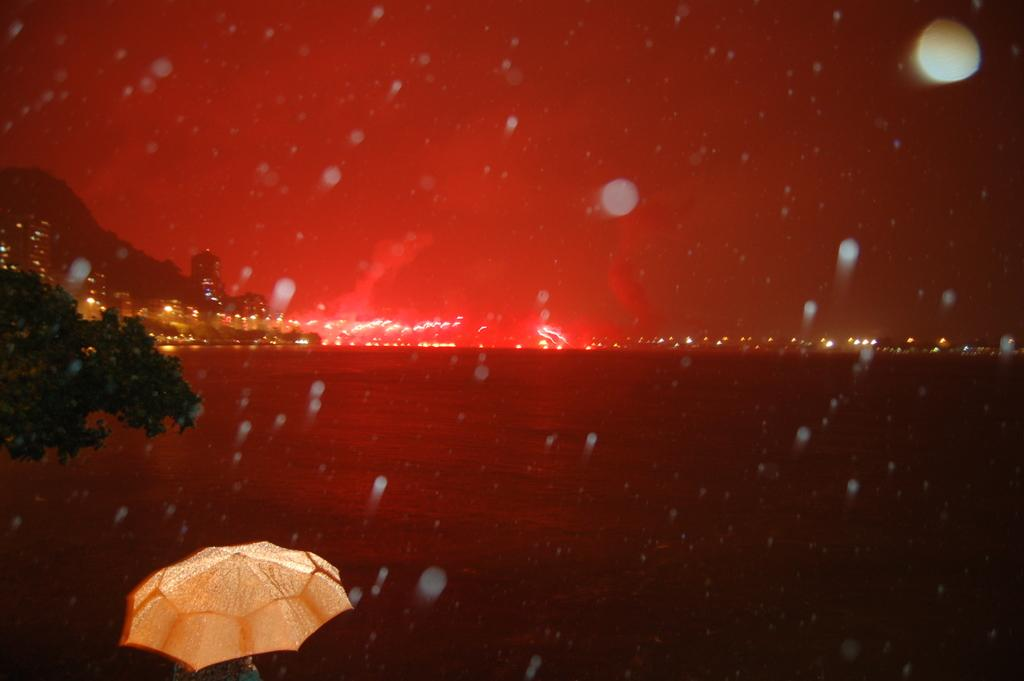What object is present in the image to provide shelter from the rain or sun? There is an umbrella in the image. What type of natural elements can be seen in the image? There are leaves and a mountain visible in the image. What is the liquid present in the image? There is water in the image. What artificial light sources are present in the image? There are lights in the image. How does the umbrella help the person jump higher in the image? The umbrella does not help the person jump higher in the image, as it is not a tool for jumping. What type of educational institution is present in the image? There is no educational institution present in the image. Where is the airplane located in the image? There is no airplane present in the image. 